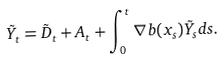<formula> <loc_0><loc_0><loc_500><loc_500>\tilde { Y } _ { t } = \tilde { D } _ { t } + A _ { t } + \int _ { 0 } ^ { t } \nabla b ( x _ { s } ) \tilde { Y } _ { s } d s .</formula> 